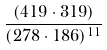<formula> <loc_0><loc_0><loc_500><loc_500>\frac { ( 4 1 9 \cdot 3 1 9 ) } { ( 2 7 8 \cdot 1 8 6 ) ^ { 1 1 } }</formula> 